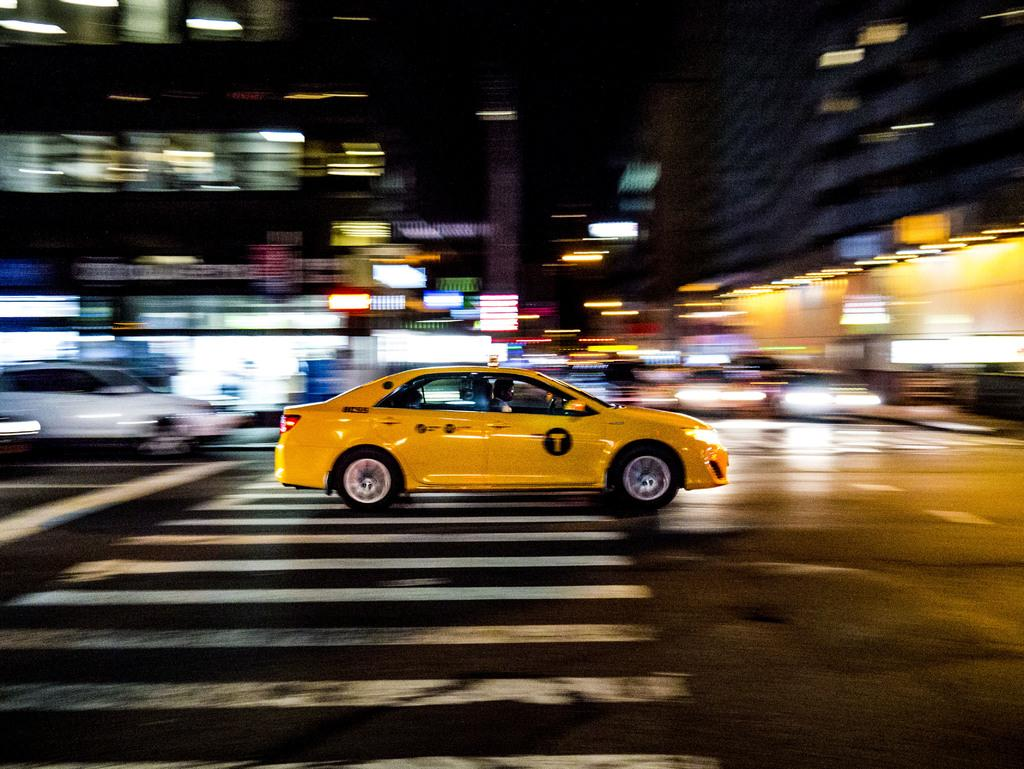<image>
Summarize the visual content of the image. A yellow taxi has the letter T on its front door. 